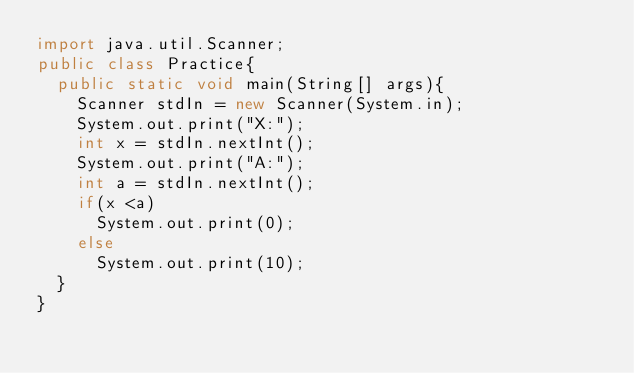<code> <loc_0><loc_0><loc_500><loc_500><_Java_>import java.util.Scanner;
public class Practice{
	public static void main(String[] args){
		Scanner stdIn = new Scanner(System.in);
		System.out.print("X:");
		int x = stdIn.nextInt();
		System.out.print("A:");
		int a = stdIn.nextInt();
		if(x <a)
			System.out.print(0);
		else
			System.out.print(10);
	}
}</code> 